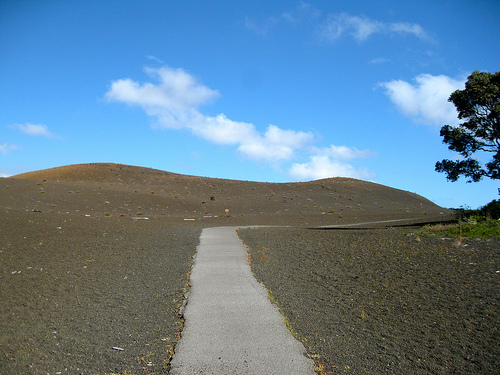<image>
Can you confirm if the tree is on the cloud? No. The tree is not positioned on the cloud. They may be near each other, but the tree is not supported by or resting on top of the cloud. Is the sky under the road? Yes. The sky is positioned underneath the road, with the road above it in the vertical space. 